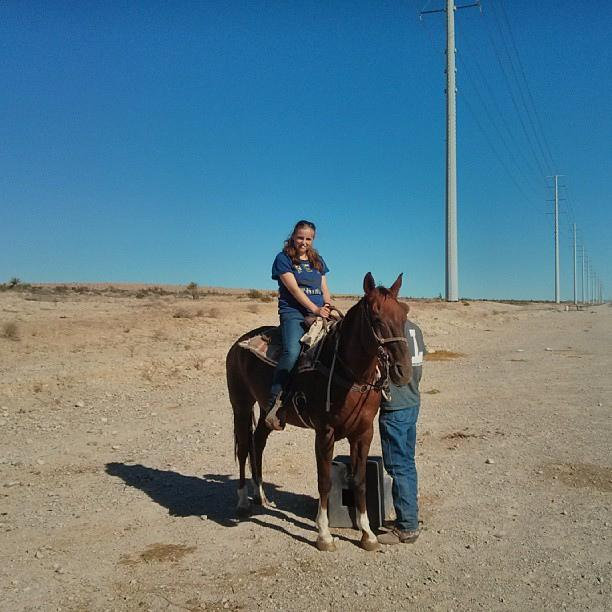If you want to use this transport what can you feed it?

Choices:
A) electricity
B) carrots
C) coal
D) gas carrots 